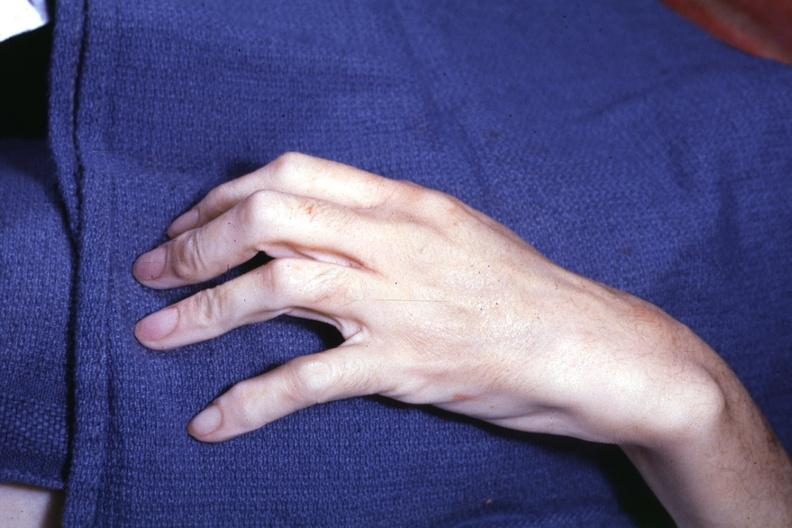re hyalin mass in pituitary which is amyloid there are several slides from this case in this file 23 yowf amyloid limited to brain present?
Answer the question using a single word or phrase. No 